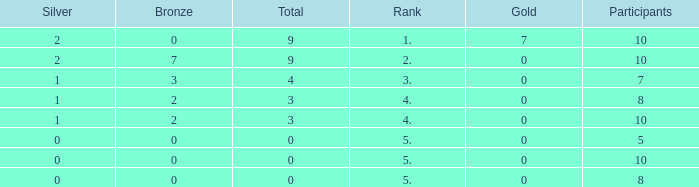What is the total number of Participants that has Silver that's smaller than 0? None. 